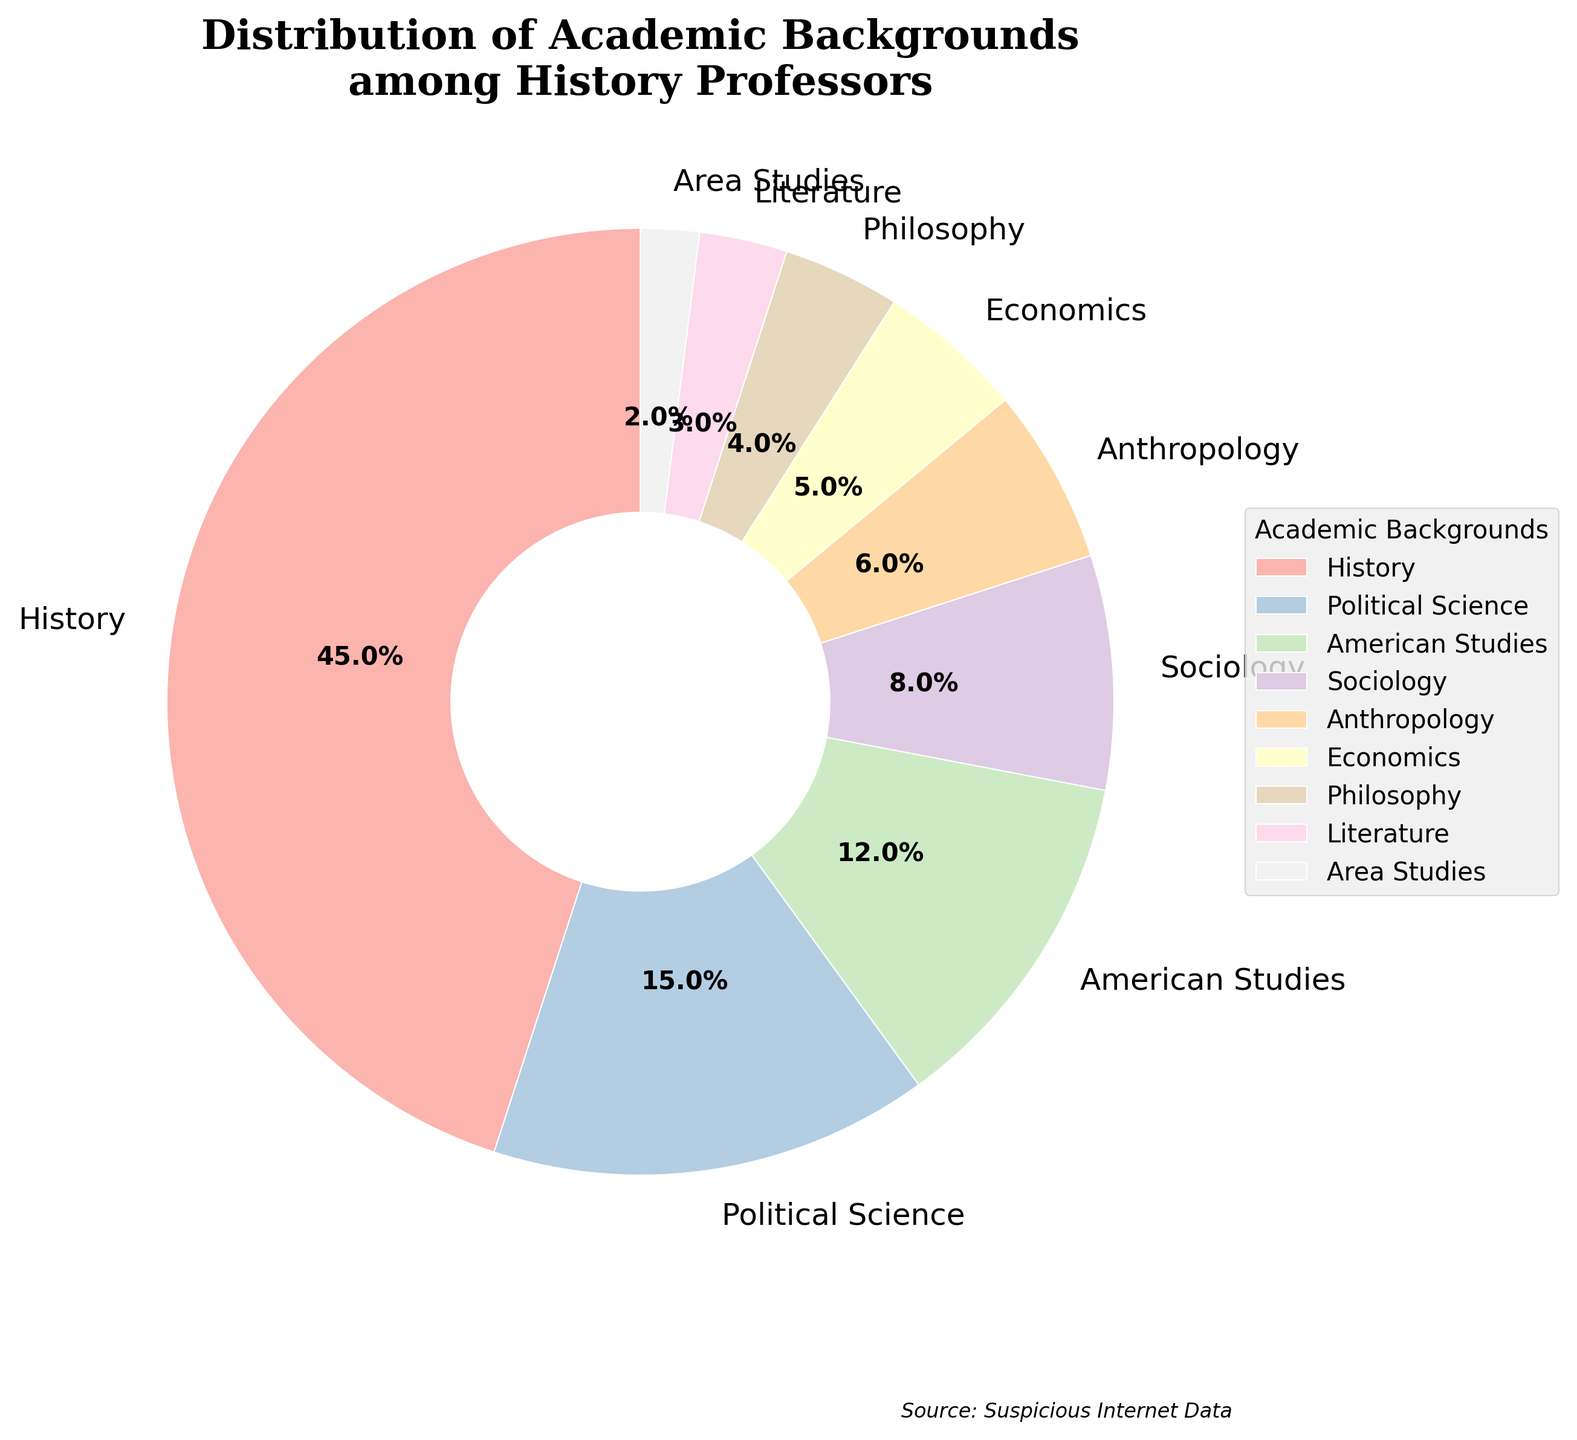What is the percentage of history professors with a background in Sociology? The pie chart indicates the distribution of various academic backgrounds. Locate the section labeled "Sociology" and observe the percentage value displayed beside it.
Answer: 8% What is the combined percentage of history professors with a background in Political Science and American Studies? Identify the percentages for Political Science and American Studies from the pie chart. Add these two percentages together: 15% (Political Science) + 12% (American Studies) = 27%.
Answer: 27% Which academic background among history professors has the lowest representation? Look at the sections of the pie chart, each labeled with different academic backgrounds and their respective percentages. Identify the background with the smallest percentage.
Answer: Area Studies By how much does the percentage of history professors with a background in History exceed those in Economics? Find the percentages for History and Economics in the pie chart. Subtract the percentage of Economics from the percentage of History: 45% (History) - 5% (Economics) = 40%.
Answer: 40% What's the total percentage of history professors with backgrounds other than History, Political Science, and American Studies? First, sum the percentages for History, Political Science, and American Studies. Then subtract this sum from 100% to get the combined percentage of the remaining backgrounds: 100% - (45% + 15% + 12%) = 28%.
Answer: 28% What is the percentage difference between history professors with backgrounds in Anthropology and Philosophy? Locate the percentages for Anthropology and Philosophy in the pie chart. Subtract the smaller percentage from the larger one: 6% (Anthropology) - 4% (Philosophy) = 2%.
Answer: 2% Which academic background has about half the representation of Sociology? Note the percentage of Sociology, which is 8%. Identify the section with a percentage close to half of 8%, which is around 4%.
Answer: Philosophy How many academic backgrounds have a representation of less than 10% among history professors? List out backgrounds with percentages less than 10% from the pie chart: Sociology (8%), Anthropology (6%), Economics (5%), Philosophy (4%), Literature (3%), Area Studies (2%). Count these sections.
Answer: 6 Do more history professors have a background in Literature or Economics? Compare the percentage values of Literature and Economics in the pie chart. The section with the higher percentage is the answer.
Answer: Economics What's the visual property used to distinguish the different academic backgrounds in the pie chart? The pie chart uses distinct colors for each segment representing different academic backgrounds, which helps in visually distinguishing them.
Answer: Colors 